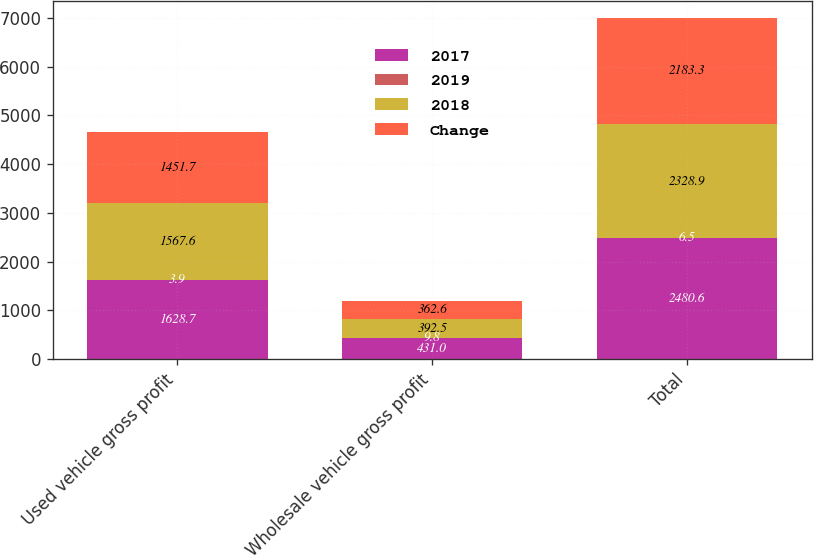<chart> <loc_0><loc_0><loc_500><loc_500><stacked_bar_chart><ecel><fcel>Used vehicle gross profit<fcel>Wholesale vehicle gross profit<fcel>Total<nl><fcel>2017<fcel>1628.7<fcel>431<fcel>2480.6<nl><fcel>2019<fcel>3.9<fcel>9.8<fcel>6.5<nl><fcel>2018<fcel>1567.6<fcel>392.5<fcel>2328.9<nl><fcel>Change<fcel>1451.7<fcel>362.6<fcel>2183.3<nl></chart> 